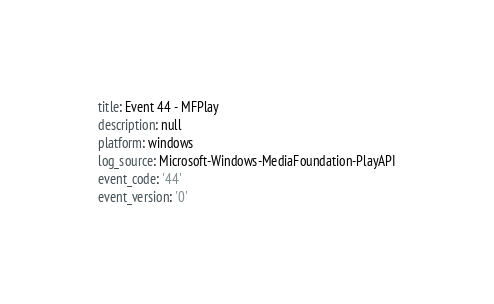<code> <loc_0><loc_0><loc_500><loc_500><_YAML_>title: Event 44 - MFPlay
description: null
platform: windows
log_source: Microsoft-Windows-MediaFoundation-PlayAPI
event_code: '44'
event_version: '0'</code> 